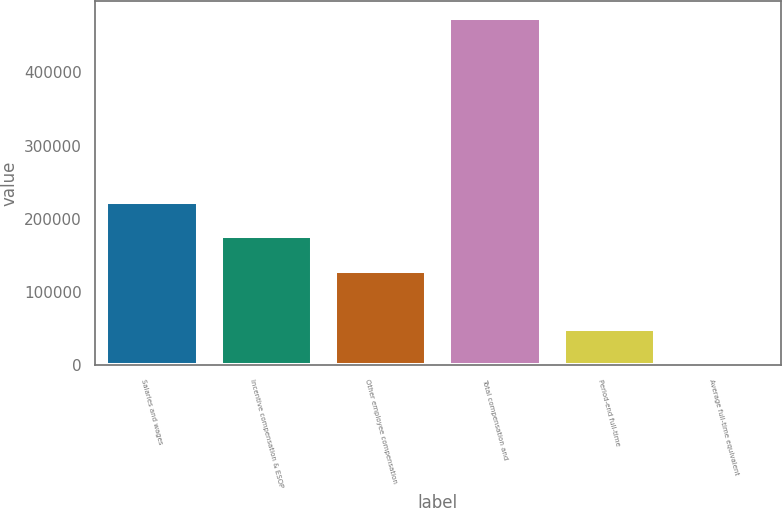Convert chart to OTSL. <chart><loc_0><loc_0><loc_500><loc_500><bar_chart><fcel>Salaries and wages<fcel>Incentive compensation & ESOP<fcel>Other employee compensation<fcel>Total compensation and<fcel>Period-end full-time<fcel>Average full-time equivalent<nl><fcel>223365<fcel>176182<fcel>128998<fcel>473841<fcel>49187.7<fcel>2004<nl></chart> 